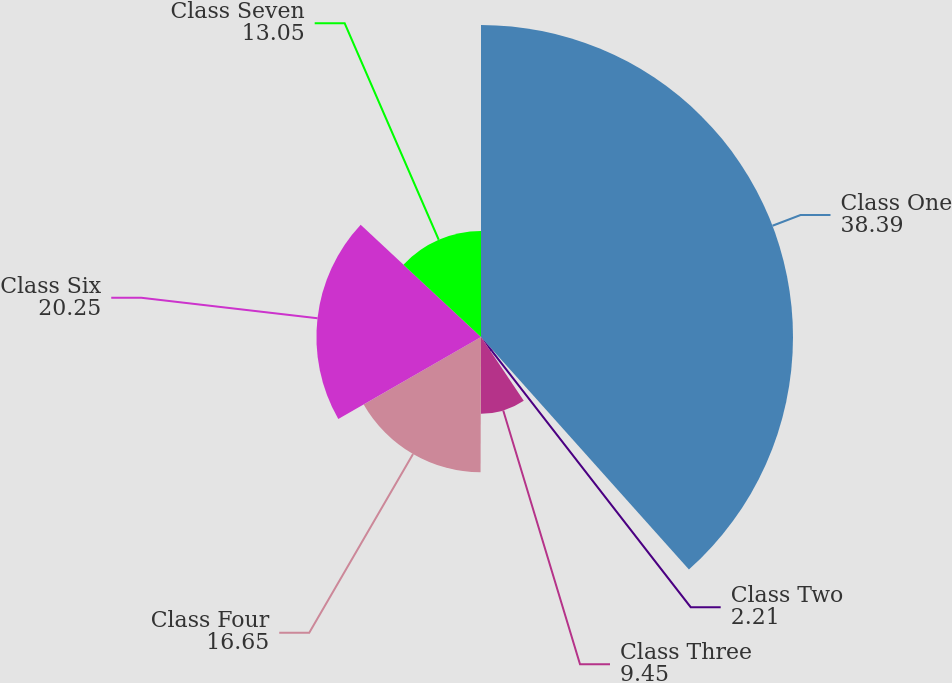Convert chart to OTSL. <chart><loc_0><loc_0><loc_500><loc_500><pie_chart><fcel>Class One<fcel>Class Two<fcel>Class Three<fcel>Class Four<fcel>Class Six<fcel>Class Seven<nl><fcel>38.39%<fcel>2.21%<fcel>9.45%<fcel>16.65%<fcel>20.25%<fcel>13.05%<nl></chart> 